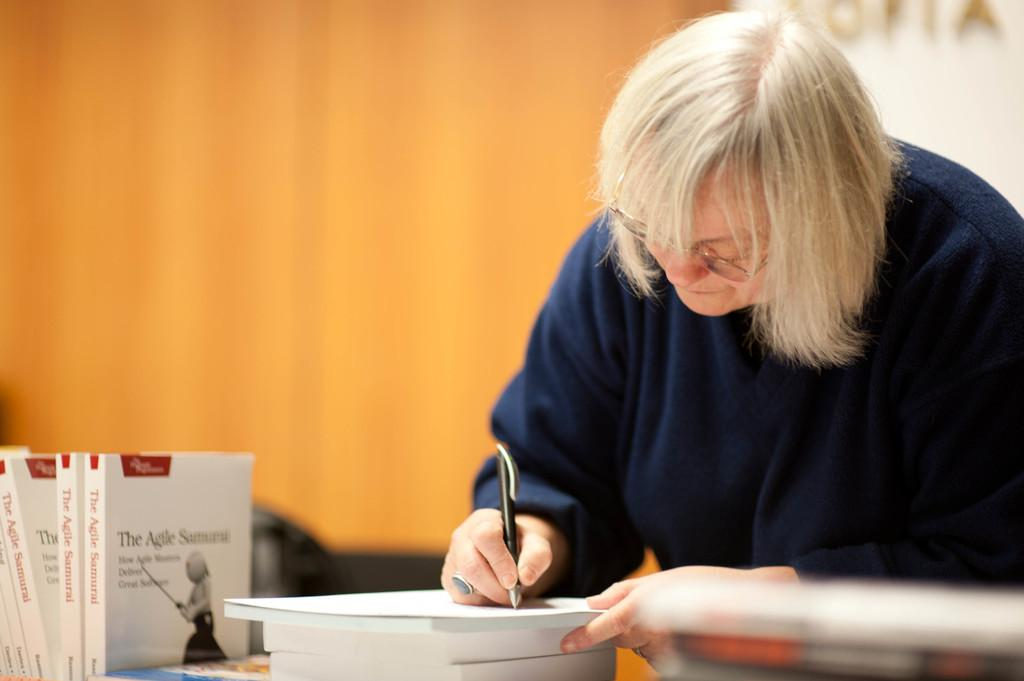<image>
Give a short and clear explanation of the subsequent image. An author signs copies of her book called The Agile Samurai. 